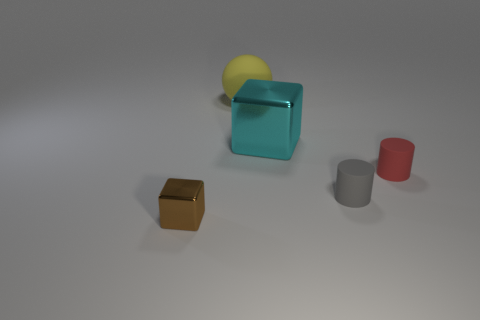Is the number of tiny blocks behind the cyan metal block the same as the number of small gray things?
Offer a very short reply. No. What number of things are either things to the right of the brown metallic thing or gray matte things?
Ensure brevity in your answer.  4. The rubber thing that is behind the tiny gray cylinder and right of the big rubber thing has what shape?
Make the answer very short. Cylinder. How many objects are large things that are on the left side of the big cyan shiny cube or small objects to the right of the cyan object?
Keep it short and to the point. 3. How many other objects are there of the same size as the gray matte cylinder?
Offer a terse response. 2. Does the metallic block that is behind the brown metal cube have the same color as the big matte sphere?
Your response must be concise. No. How big is the object that is both left of the cyan metal object and right of the small brown cube?
Provide a short and direct response. Large. How many big things are either purple shiny things or cyan metal things?
Make the answer very short. 1. What shape is the metallic object that is right of the brown cube?
Your answer should be compact. Cube. How many tiny red objects are there?
Your answer should be compact. 1. 